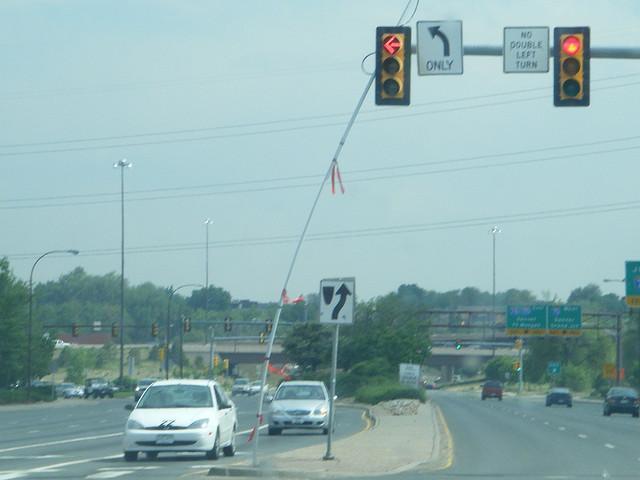How many cars can be seen?
Give a very brief answer. 2. How many traffic lights are in the picture?
Give a very brief answer. 2. 